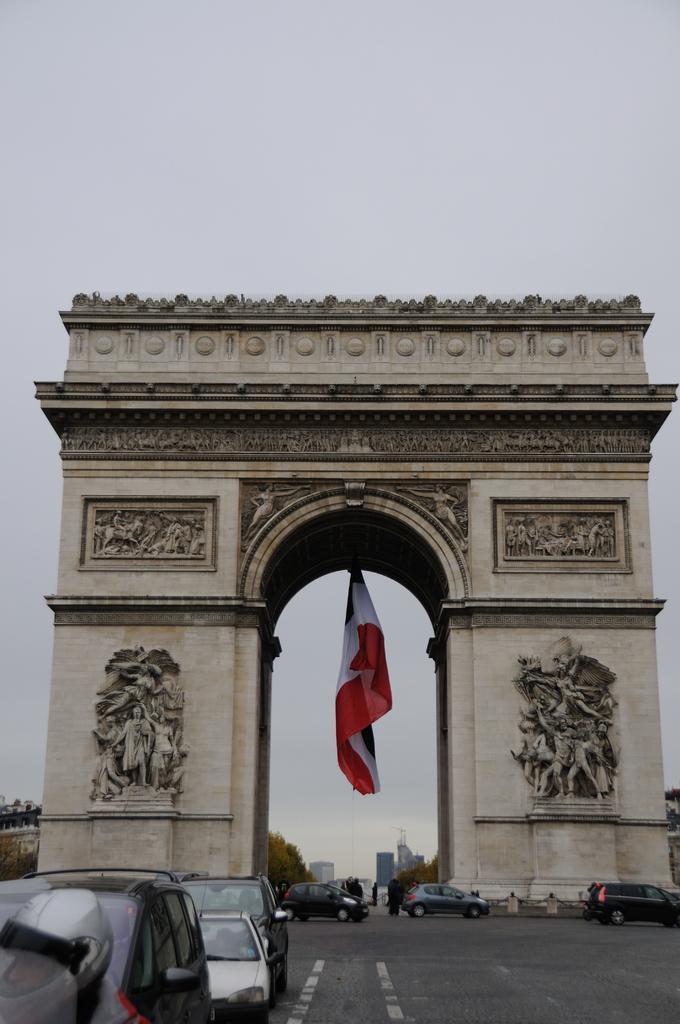Please provide a concise description of this image. In the middle of the image we can see a flag and an arch, in front of the arch we can find few people and vehicles on the road, in the background we can see few buildings and trees. 